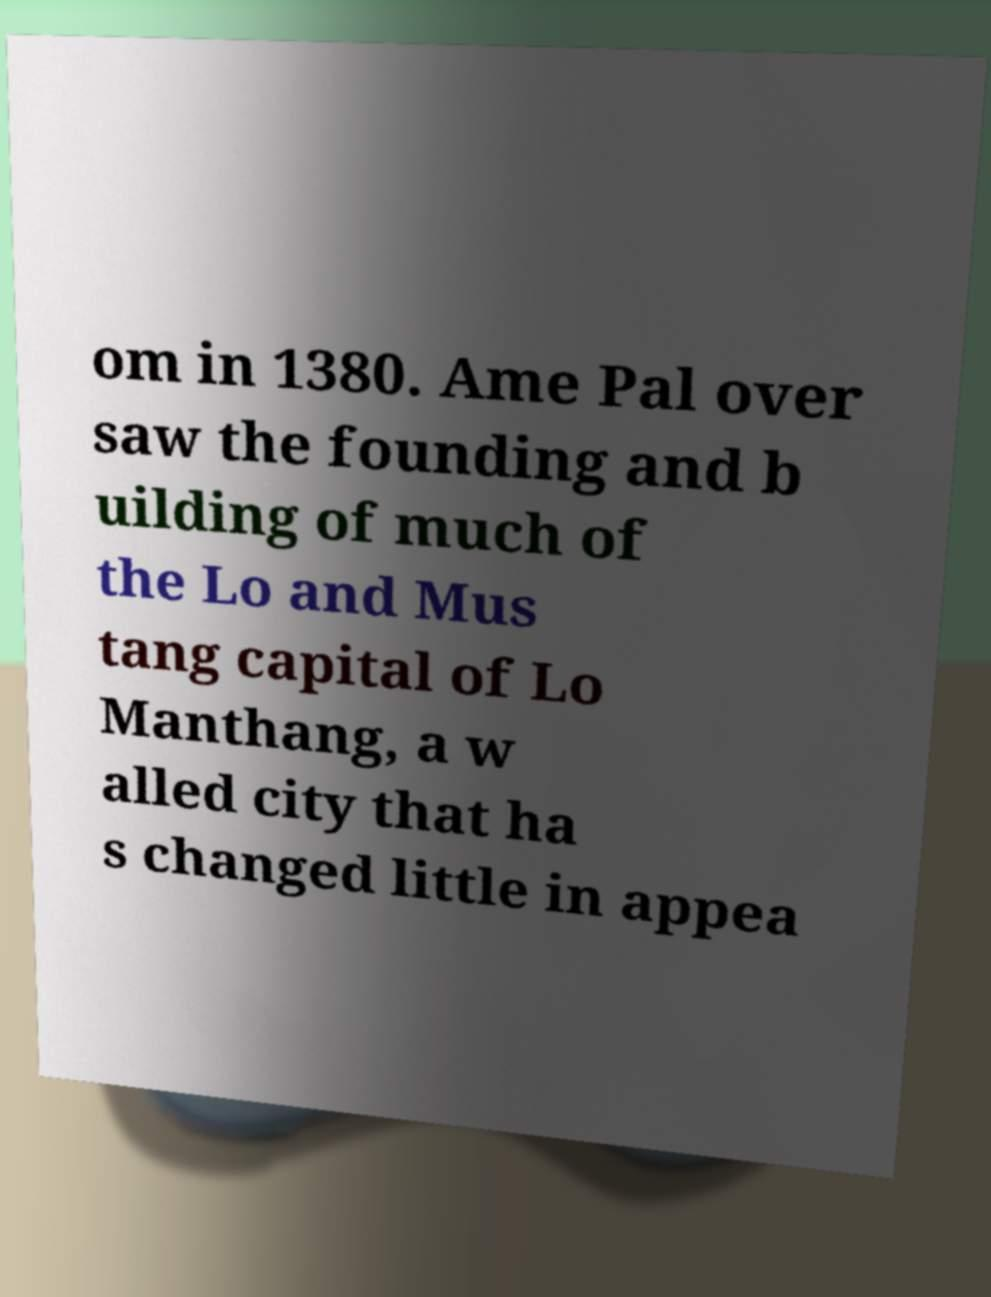There's text embedded in this image that I need extracted. Can you transcribe it verbatim? om in 1380. Ame Pal over saw the founding and b uilding of much of the Lo and Mus tang capital of Lo Manthang, a w alled city that ha s changed little in appea 